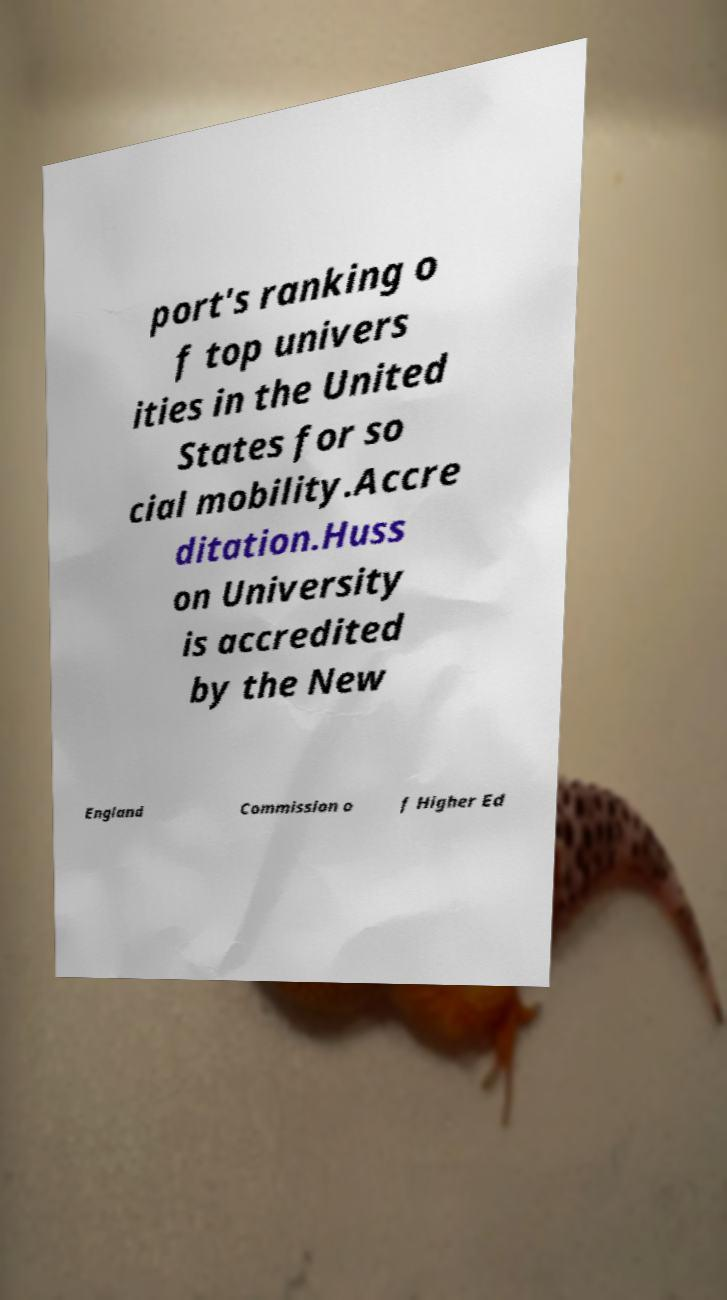There's text embedded in this image that I need extracted. Can you transcribe it verbatim? port's ranking o f top univers ities in the United States for so cial mobility.Accre ditation.Huss on University is accredited by the New England Commission o f Higher Ed 